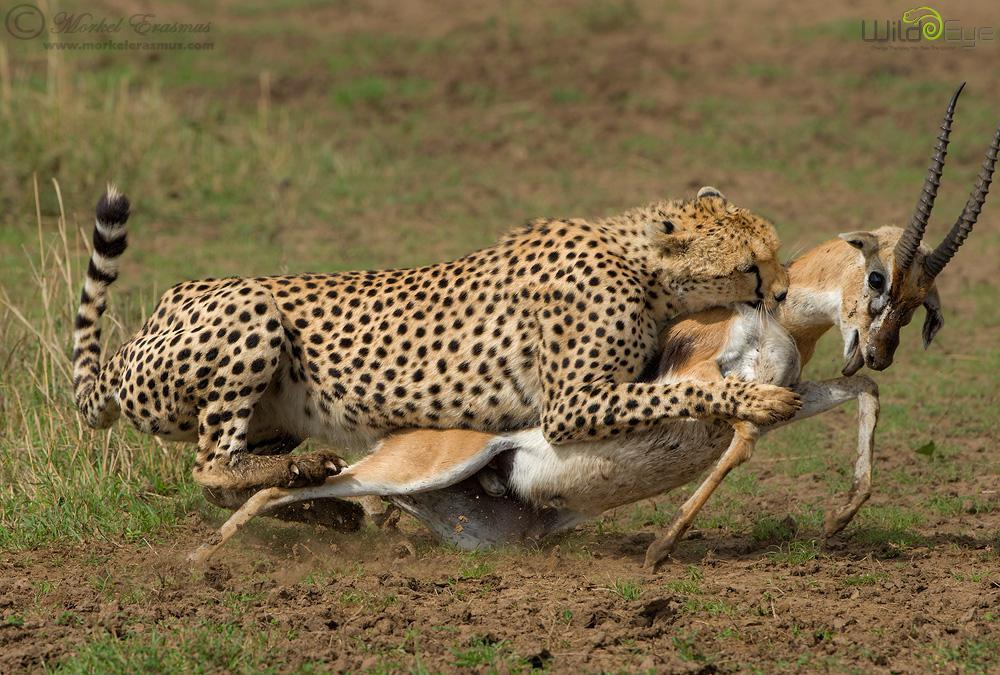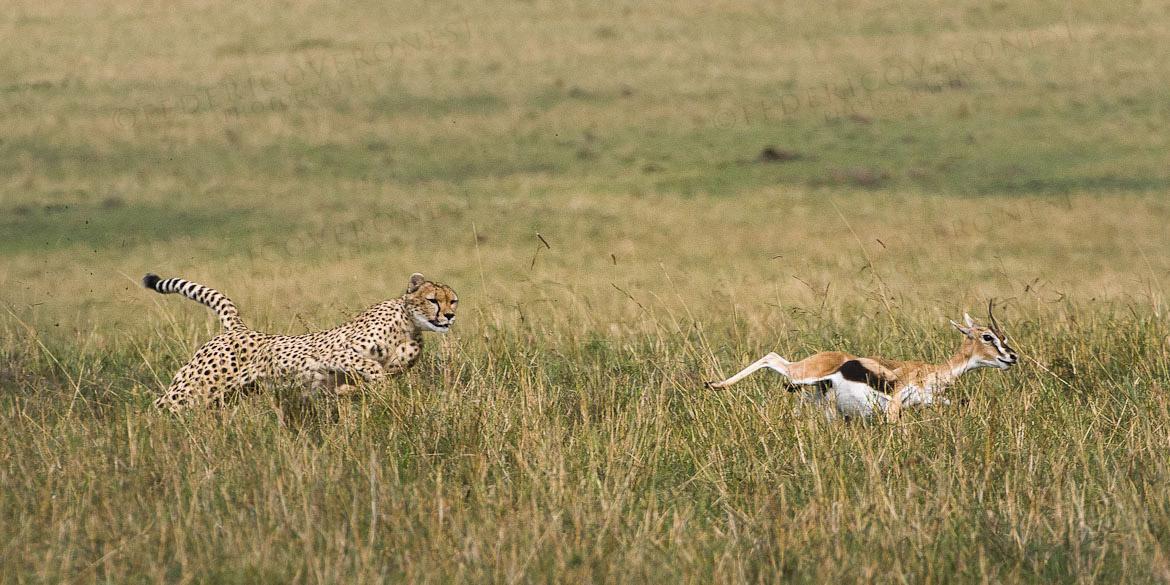The first image is the image on the left, the second image is the image on the right. Analyze the images presented: Is the assertion "The sky is visible in the background of at least one of the images." valid? Answer yes or no. No. The first image is the image on the left, the second image is the image on the right. Assess this claim about the two images: "One of the cheetahs is touching its prey.". Correct or not? Answer yes or no. Yes. 